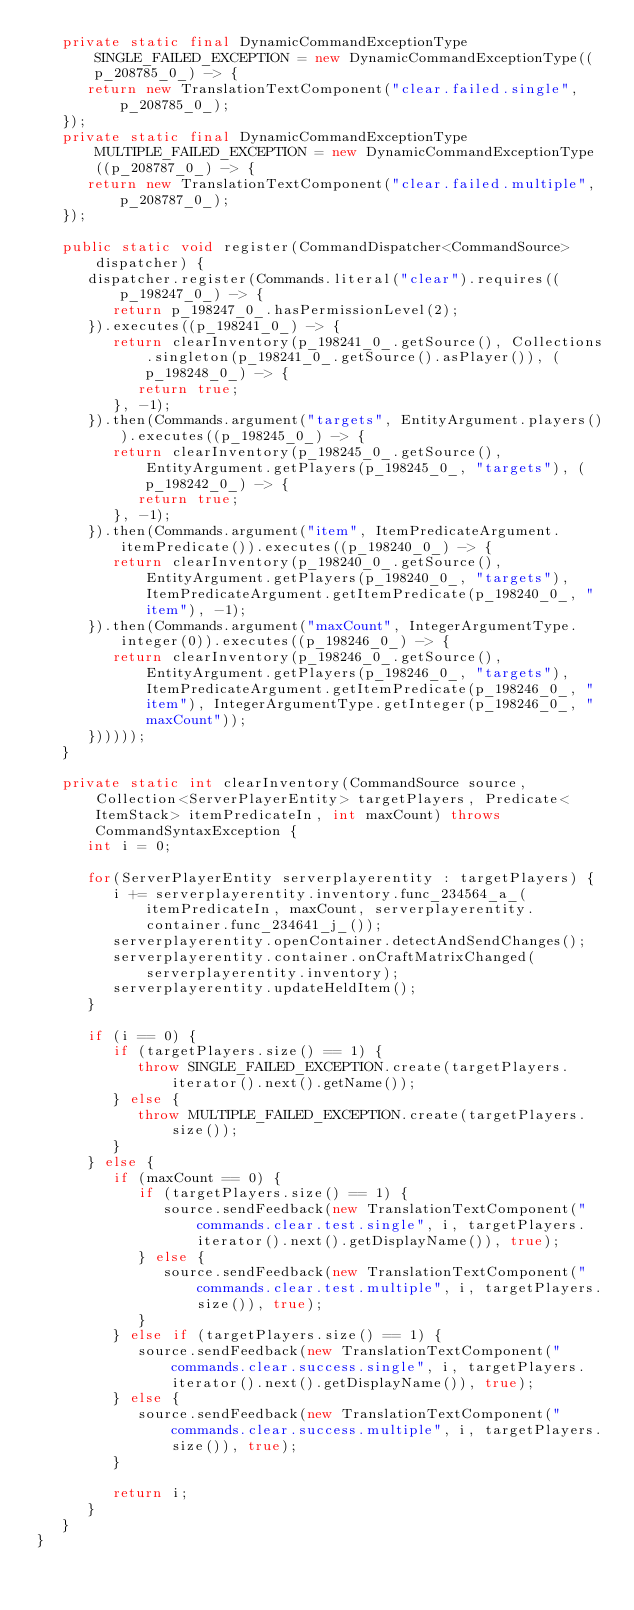<code> <loc_0><loc_0><loc_500><loc_500><_Java_>   private static final DynamicCommandExceptionType SINGLE_FAILED_EXCEPTION = new DynamicCommandExceptionType((p_208785_0_) -> {
      return new TranslationTextComponent("clear.failed.single", p_208785_0_);
   });
   private static final DynamicCommandExceptionType MULTIPLE_FAILED_EXCEPTION = new DynamicCommandExceptionType((p_208787_0_) -> {
      return new TranslationTextComponent("clear.failed.multiple", p_208787_0_);
   });

   public static void register(CommandDispatcher<CommandSource> dispatcher) {
      dispatcher.register(Commands.literal("clear").requires((p_198247_0_) -> {
         return p_198247_0_.hasPermissionLevel(2);
      }).executes((p_198241_0_) -> {
         return clearInventory(p_198241_0_.getSource(), Collections.singleton(p_198241_0_.getSource().asPlayer()), (p_198248_0_) -> {
            return true;
         }, -1);
      }).then(Commands.argument("targets", EntityArgument.players()).executes((p_198245_0_) -> {
         return clearInventory(p_198245_0_.getSource(), EntityArgument.getPlayers(p_198245_0_, "targets"), (p_198242_0_) -> {
            return true;
         }, -1);
      }).then(Commands.argument("item", ItemPredicateArgument.itemPredicate()).executes((p_198240_0_) -> {
         return clearInventory(p_198240_0_.getSource(), EntityArgument.getPlayers(p_198240_0_, "targets"), ItemPredicateArgument.getItemPredicate(p_198240_0_, "item"), -1);
      }).then(Commands.argument("maxCount", IntegerArgumentType.integer(0)).executes((p_198246_0_) -> {
         return clearInventory(p_198246_0_.getSource(), EntityArgument.getPlayers(p_198246_0_, "targets"), ItemPredicateArgument.getItemPredicate(p_198246_0_, "item"), IntegerArgumentType.getInteger(p_198246_0_, "maxCount"));
      })))));
   }

   private static int clearInventory(CommandSource source, Collection<ServerPlayerEntity> targetPlayers, Predicate<ItemStack> itemPredicateIn, int maxCount) throws CommandSyntaxException {
      int i = 0;

      for(ServerPlayerEntity serverplayerentity : targetPlayers) {
         i += serverplayerentity.inventory.func_234564_a_(itemPredicateIn, maxCount, serverplayerentity.container.func_234641_j_());
         serverplayerentity.openContainer.detectAndSendChanges();
         serverplayerentity.container.onCraftMatrixChanged(serverplayerentity.inventory);
         serverplayerentity.updateHeldItem();
      }

      if (i == 0) {
         if (targetPlayers.size() == 1) {
            throw SINGLE_FAILED_EXCEPTION.create(targetPlayers.iterator().next().getName());
         } else {
            throw MULTIPLE_FAILED_EXCEPTION.create(targetPlayers.size());
         }
      } else {
         if (maxCount == 0) {
            if (targetPlayers.size() == 1) {
               source.sendFeedback(new TranslationTextComponent("commands.clear.test.single", i, targetPlayers.iterator().next().getDisplayName()), true);
            } else {
               source.sendFeedback(new TranslationTextComponent("commands.clear.test.multiple", i, targetPlayers.size()), true);
            }
         } else if (targetPlayers.size() == 1) {
            source.sendFeedback(new TranslationTextComponent("commands.clear.success.single", i, targetPlayers.iterator().next().getDisplayName()), true);
         } else {
            source.sendFeedback(new TranslationTextComponent("commands.clear.success.multiple", i, targetPlayers.size()), true);
         }

         return i;
      }
   }
}</code> 